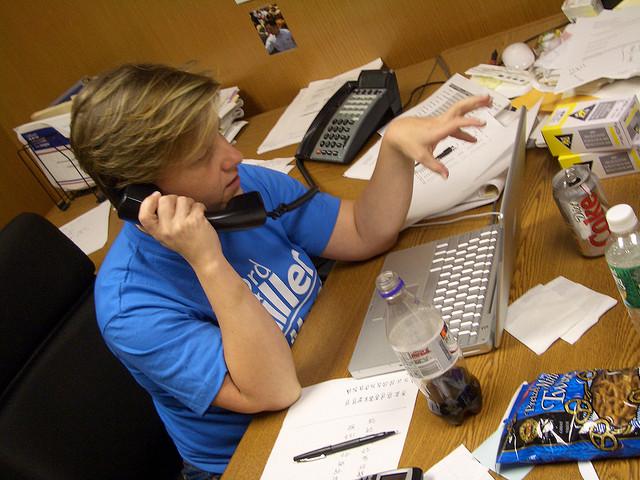How many bottles are on this desk?
Write a very short answer. 2. What is the person drinking?
Be succinct. Diet coke. Is she talking on the telephone?
Keep it brief. Yes. 